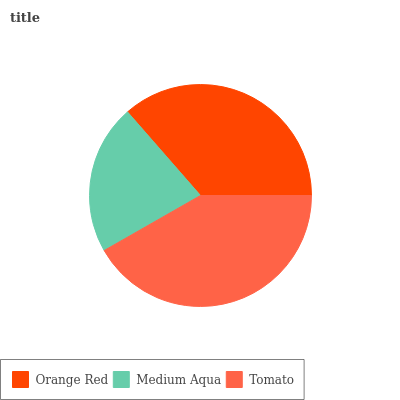Is Medium Aqua the minimum?
Answer yes or no. Yes. Is Tomato the maximum?
Answer yes or no. Yes. Is Tomato the minimum?
Answer yes or no. No. Is Medium Aqua the maximum?
Answer yes or no. No. Is Tomato greater than Medium Aqua?
Answer yes or no. Yes. Is Medium Aqua less than Tomato?
Answer yes or no. Yes. Is Medium Aqua greater than Tomato?
Answer yes or no. No. Is Tomato less than Medium Aqua?
Answer yes or no. No. Is Orange Red the high median?
Answer yes or no. Yes. Is Orange Red the low median?
Answer yes or no. Yes. Is Tomato the high median?
Answer yes or no. No. Is Medium Aqua the low median?
Answer yes or no. No. 